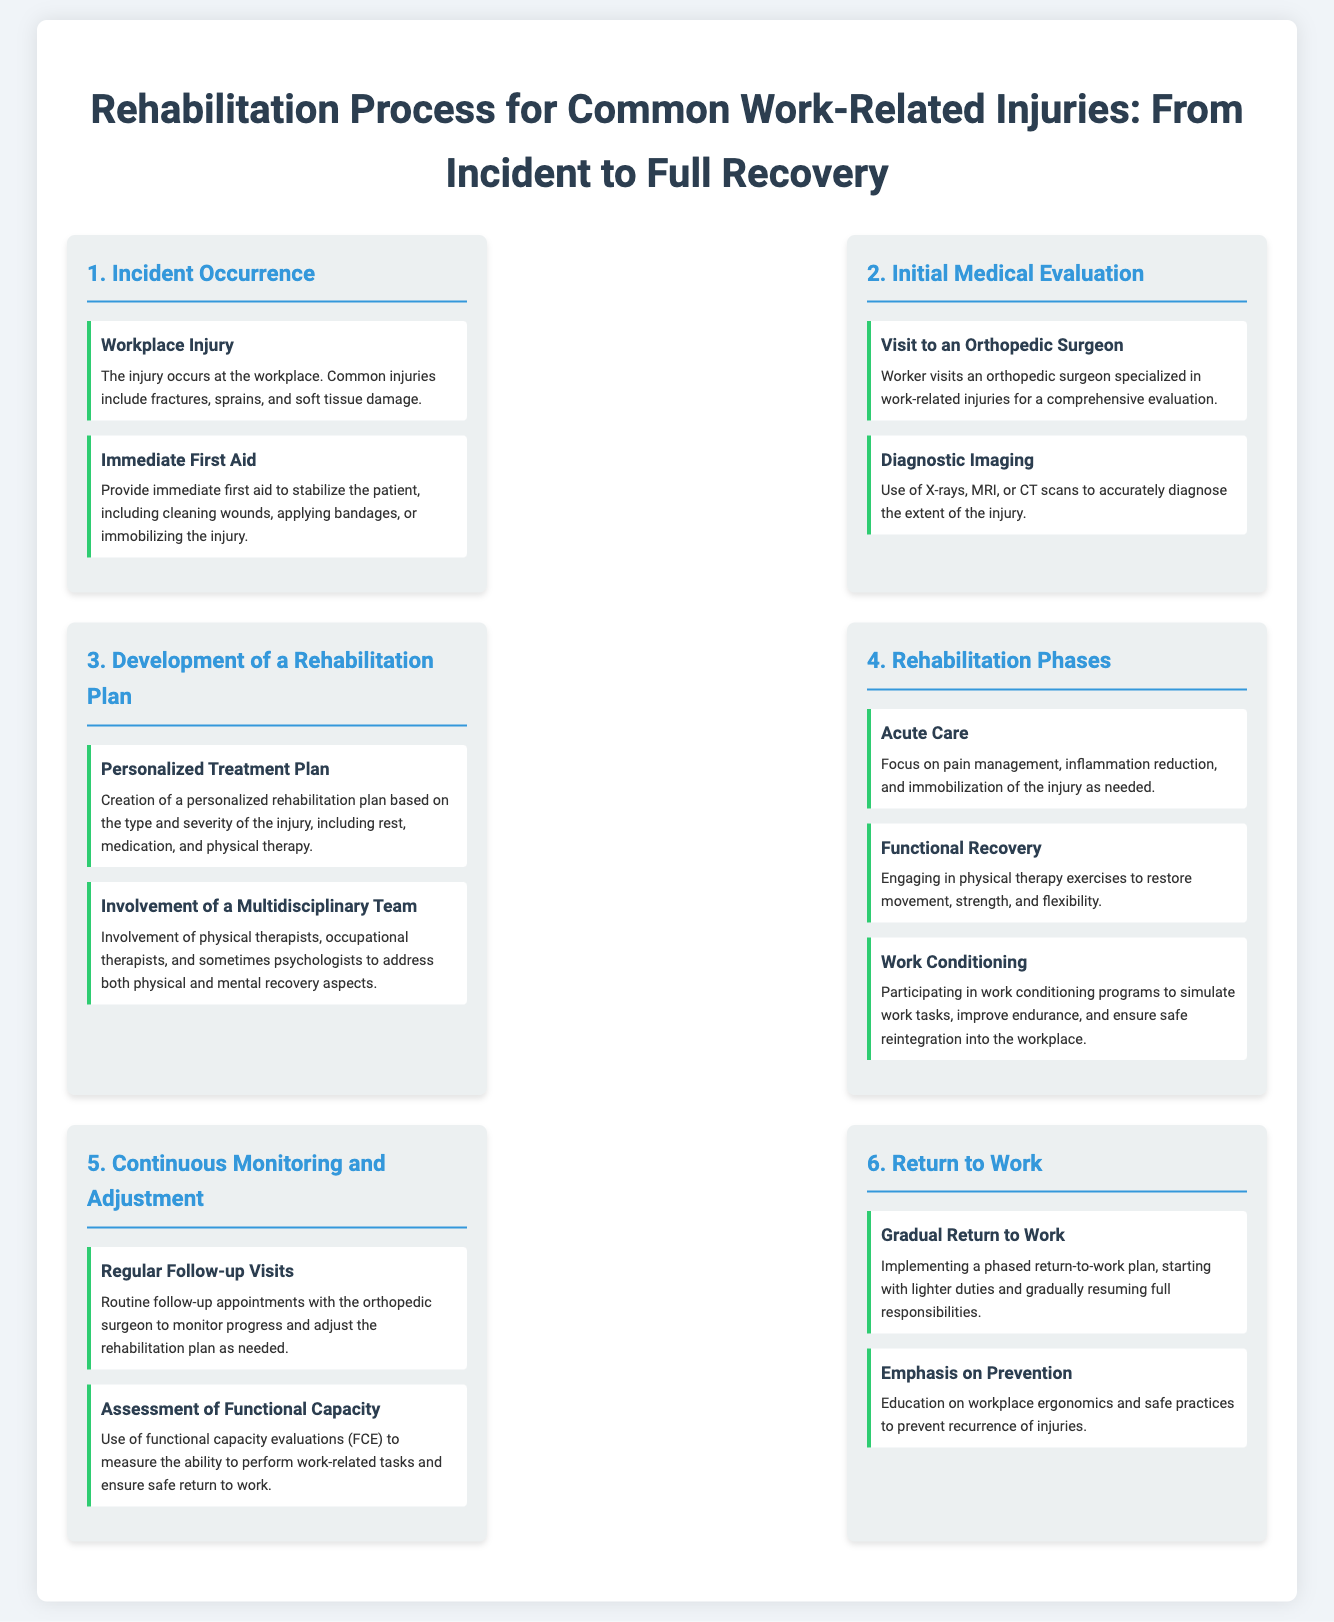what are the common injuries mentioned? The document lists fractures, sprains, and soft tissue damage as common work-related injuries.
Answer: fractures, sprains, soft tissue damage what should be done for immediate first aid? The document states that immediate first aid includes cleaning wounds, applying bandages, or immobilizing the injury.
Answer: cleaning wounds, applying bandages, immobilizing the injury who is involved in the development of a rehabilitation plan? It mentions the involvement of physical therapists, occupational therapists, and sometimes psychologists.
Answer: physical therapists, occupational therapists, psychologists what is the focus during the Acute Care phase? The document specifies that the focus is on pain management, inflammation reduction, and immobilization of the injury as needed.
Answer: pain management, inflammation reduction, immobilization how often should follow-up visits occur? The document suggests that routine follow-up appointments with the orthopedic surgeon should be conducted.
Answer: regularly what is evaluated to assess functional capacity? It mentions the use of functional capacity evaluations (FCE) for this purpose.
Answer: functional capacity evaluations (FCE) what type of return-to-work plan is implemented? A phased return-to-work plan is implemented according to the document.
Answer: phased return-to-work plan what is emphasized to prevent recurrences of injuries? The document emphasizes education on workplace ergonomics and safe practices.
Answer: workplace ergonomics and safe practices 